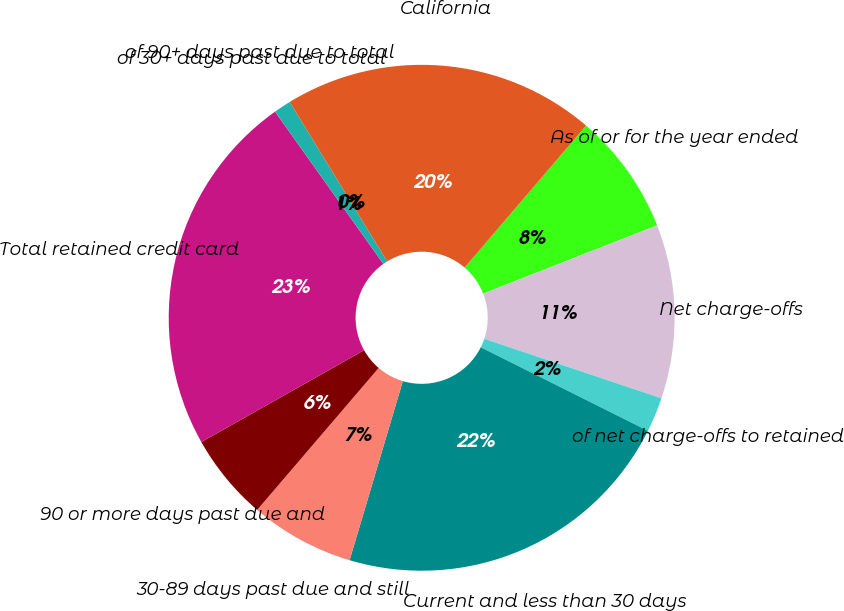<chart> <loc_0><loc_0><loc_500><loc_500><pie_chart><fcel>As of or for the year ended<fcel>Net charge-offs<fcel>of net charge-offs to retained<fcel>Current and less than 30 days<fcel>30-89 days past due and still<fcel>90 or more days past due and<fcel>Total retained credit card<fcel>of 30+ days past due to total<fcel>of 90+ days past due to total<fcel>California<nl><fcel>7.78%<fcel>11.11%<fcel>2.22%<fcel>22.22%<fcel>6.67%<fcel>5.56%<fcel>23.33%<fcel>1.11%<fcel>0.0%<fcel>20.0%<nl></chart> 